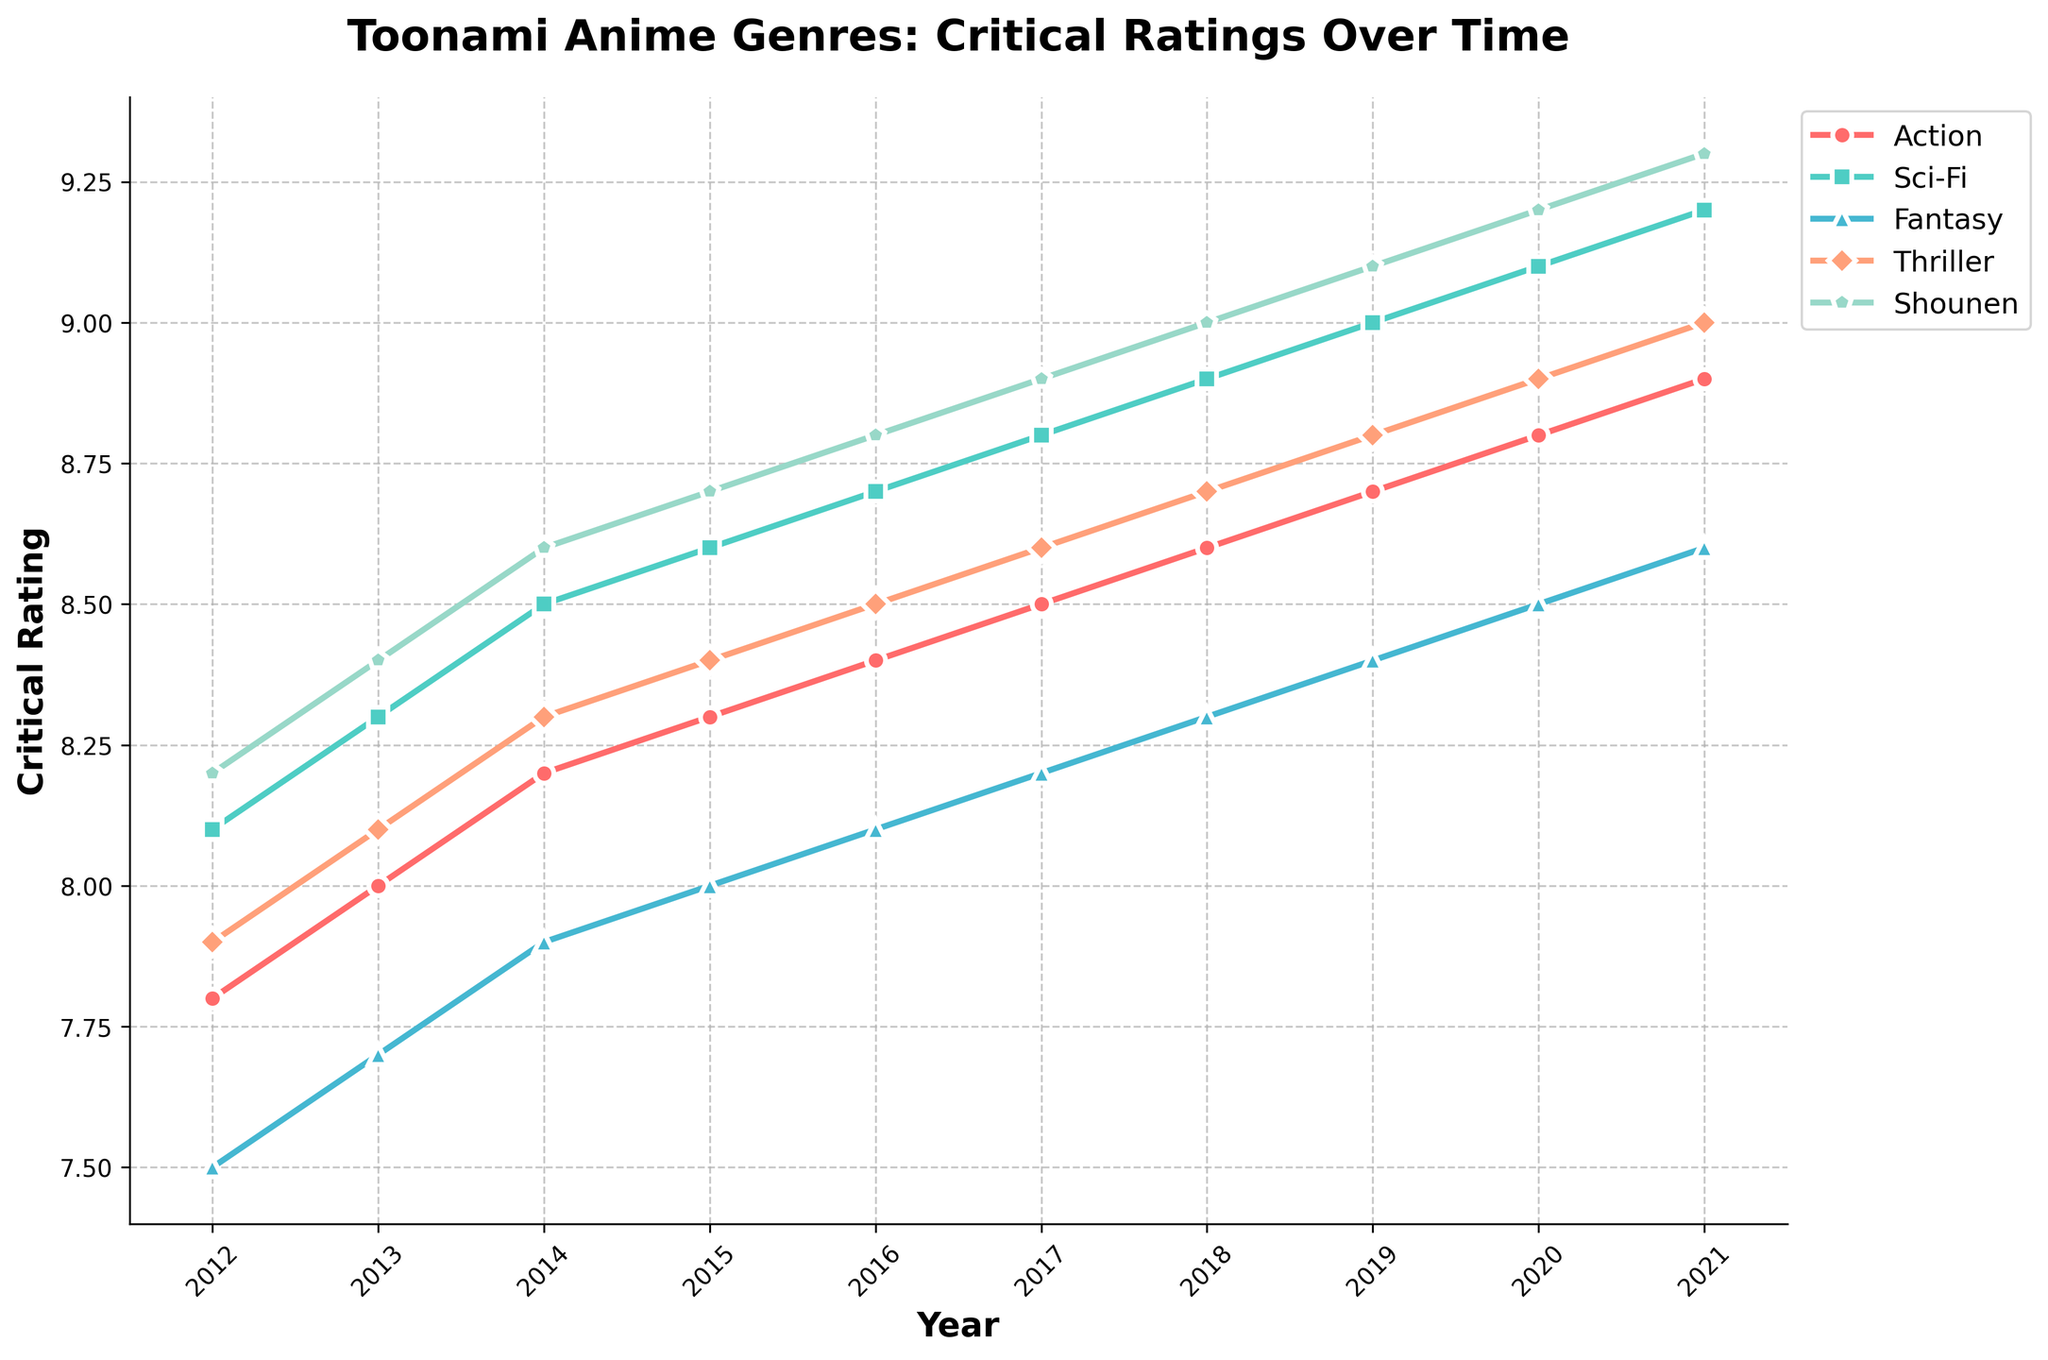What genre had the highest critical rating in 2021? Looking at the line chart and comparing the ratings for each genre in 2021, "Shounen" consistently has the highest rating.
Answer: Shounen Which genre showed the most significant improvement from 2012 to 2021? To find the biggest improvement, subtract the 2012 rating from the 2021 rating for each genre. Shounen increased from 8.2 to 9.3, which is the largest increase of 1.1.
Answer: Shounen What year did Sci-Fi surpass Action in critical ratings? By examining the plot lines of Sci-Fi and Action, we can see that Sci-Fi consistently had higher ratings even from 2012. Therefore, Sci-Fi did not necessarily surpass Action at one point but rather maintained a higher rating throughout the period.
Answer: 2012 Which genre had the smallest change in critical ratings from 2012 to 2021? To find the smallest change, subtract the 2012 rating from the 2021 rating for each genre. Fantasy had an increase from 7.5 to 8.6, which is a change of 1.1. But Thriller had an increase from 7.9 to 9.0, which is also 1.1. Therefore, Thriller should be looked into further, but Fantasy had the smallest change relative to its start.
Answer: Thriller What is the average critical rating of Action genre from 2012 to 2021? Add up all the ratings for Action from 2012 to 2021 and divide by the number of years. (7.8 + 8.0 + 8.2 + 8.3 + 8.4 + 8.5 + 8.6 + 8.7 + 8.8 + 8.9) / 10 = 84.2 / 10 = 8.42
Answer: 8.42 Which genre had a steady year-over-year increase without any drop in ratings from 2012 to 2021? By looking at the trend lines, we see that all the genres show a steady increase without any dips, but Shounen stands out for its consistent yearly growth.
Answer: Shounen In 2015, which genre had the second-highest rating? Reviewing the 2015 data points, first highest is Shounen at 8.7, and the second highest is Sci-Fi at 8.6.
Answer: Sci-Fi What is the difference in critical rating between the highest and lowest rated genre in 2020? The highest rating in 2020 is for Shounen at 9.2, and the lowest is for Fantasy at 8.5. The difference is 9.2 - 8.5 = 0.7.
Answer: 0.7 Which genre outranks Thriller in every year shown? Observing the plot lines above Thriller in every year, Shounen, Sci-Fi, and Fantasy are consistently above Thriller.
Answer: Shounen, Sci-Fi, Fantasy How many genres had a critical rating above 8.5 in 2016? In 2016, the genres with ratings above 8.5 are Shounen (8.8), Sci-Fi (8.7), Action (8.4), Thriller (8.5), so three genres fit this criteria.
Answer: 3 